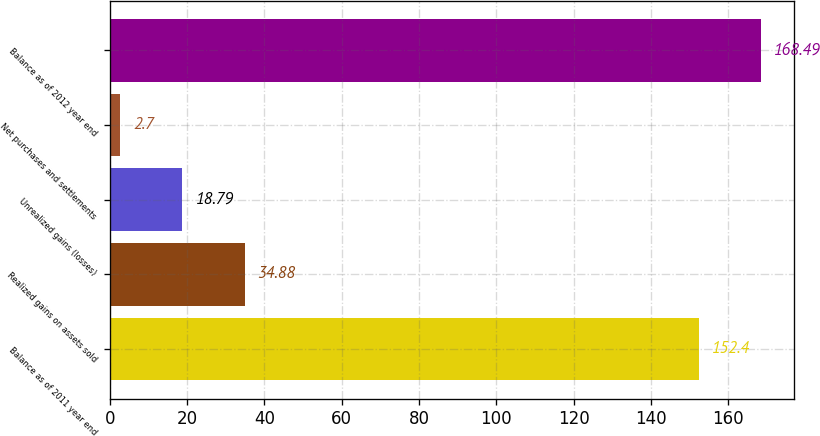<chart> <loc_0><loc_0><loc_500><loc_500><bar_chart><fcel>Balance as of 2011 year end<fcel>Realized gains on assets sold<fcel>Unrealized gains (losses)<fcel>Net purchases and settlements<fcel>Balance as of 2012 year end<nl><fcel>152.4<fcel>34.88<fcel>18.79<fcel>2.7<fcel>168.49<nl></chart> 